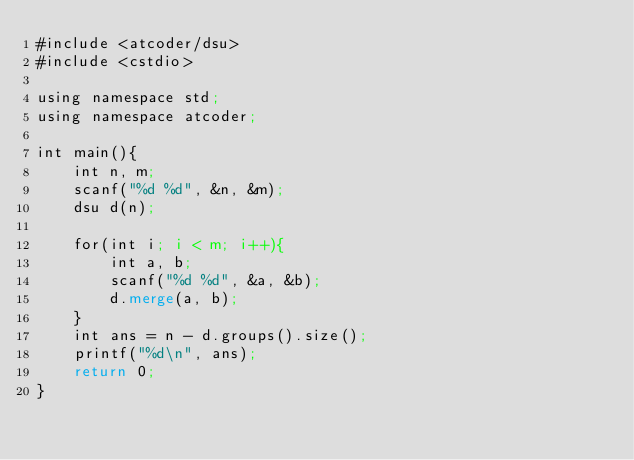<code> <loc_0><loc_0><loc_500><loc_500><_Lisp_>#include <atcoder/dsu>
#include <cstdio>

using namespace std;
using namespace atcoder;

int main(){
    int n, m;
    scanf("%d %d", &n, &m);
    dsu d(n);

    for(int i; i < m; i++){
        int a, b;
        scanf("%d %d", &a, &b);
        d.merge(a, b);
    }
    int ans = n - d.groups().size();
    printf("%d\n", ans);
    return 0;
}</code> 